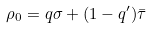Convert formula to latex. <formula><loc_0><loc_0><loc_500><loc_500>\rho _ { 0 } = q \sigma + ( 1 - q ^ { \prime } ) \bar { \tau }</formula> 